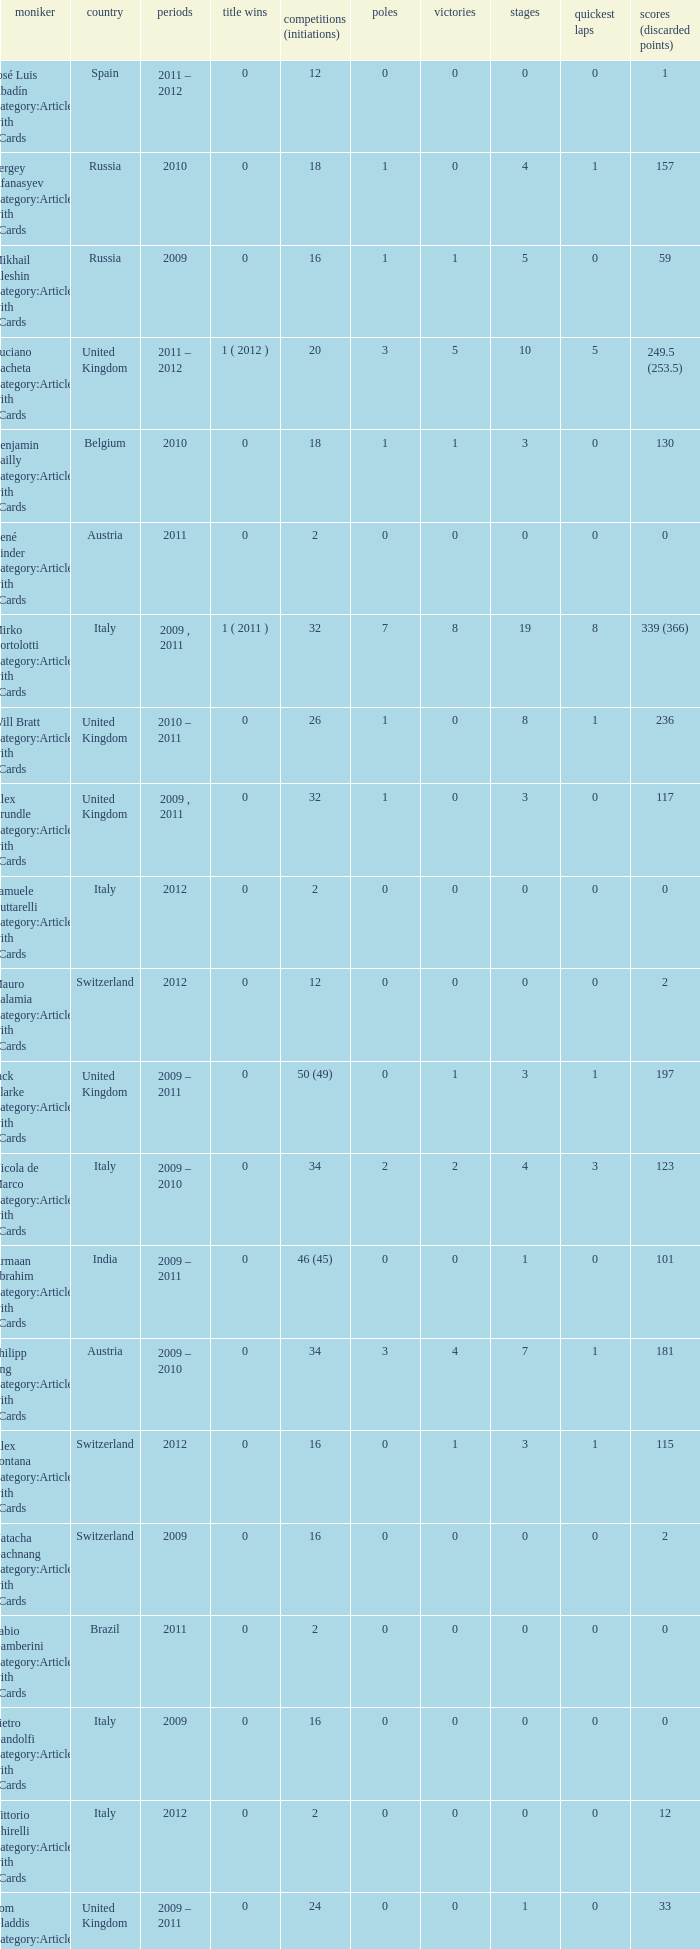What was the least amount of wins? 0.0. 